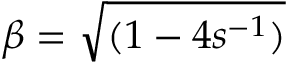Convert formula to latex. <formula><loc_0><loc_0><loc_500><loc_500>\beta = \sqrt { ( 1 - 4 s ^ { - 1 } ) }</formula> 